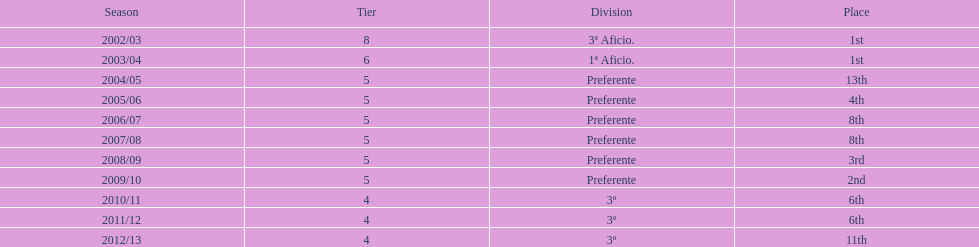How many times did internacional de madrid cf finish the season at the pinnacle of their division? 2. 